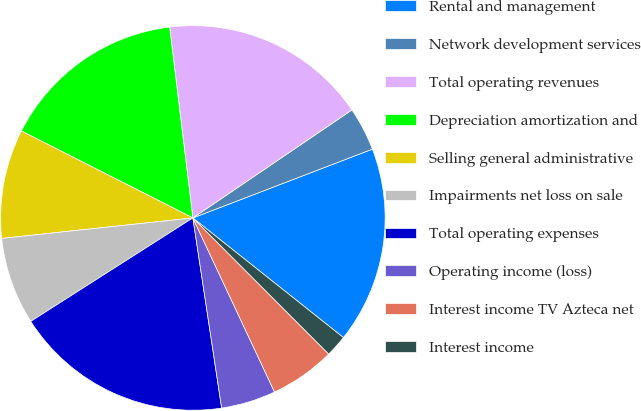<chart> <loc_0><loc_0><loc_500><loc_500><pie_chart><fcel>Rental and management<fcel>Network development services<fcel>Total operating revenues<fcel>Depreciation amortization and<fcel>Selling general administrative<fcel>Impairments net loss on sale<fcel>Total operating expenses<fcel>Operating income (loss)<fcel>Interest income TV Azteca net<fcel>Interest income<nl><fcel>16.51%<fcel>3.67%<fcel>17.43%<fcel>15.6%<fcel>9.17%<fcel>7.34%<fcel>18.35%<fcel>4.59%<fcel>5.5%<fcel>1.83%<nl></chart> 